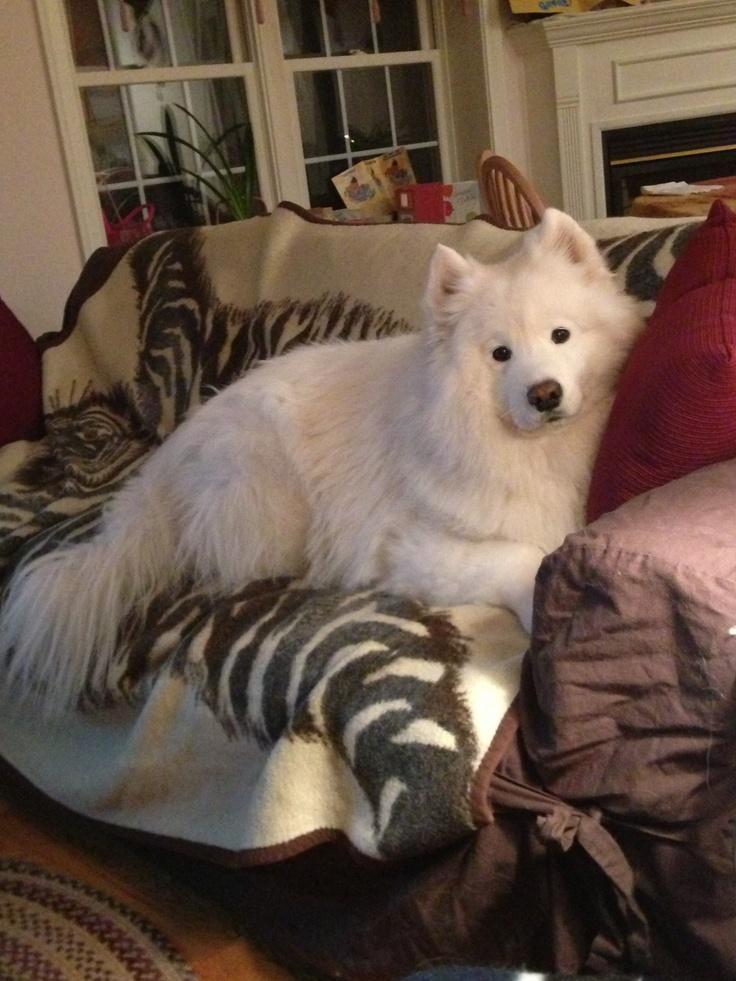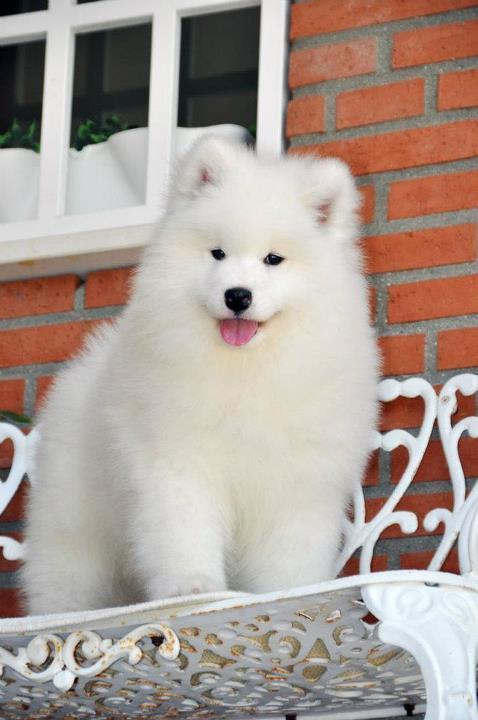The first image is the image on the left, the second image is the image on the right. Considering the images on both sides, is "Each image contains exactly one white dog, and at least one image shows a dog in a setting with furniture." valid? Answer yes or no. Yes. The first image is the image on the left, the second image is the image on the right. Analyze the images presented: Is the assertion "At least one dog is laying on a couch." valid? Answer yes or no. Yes. 